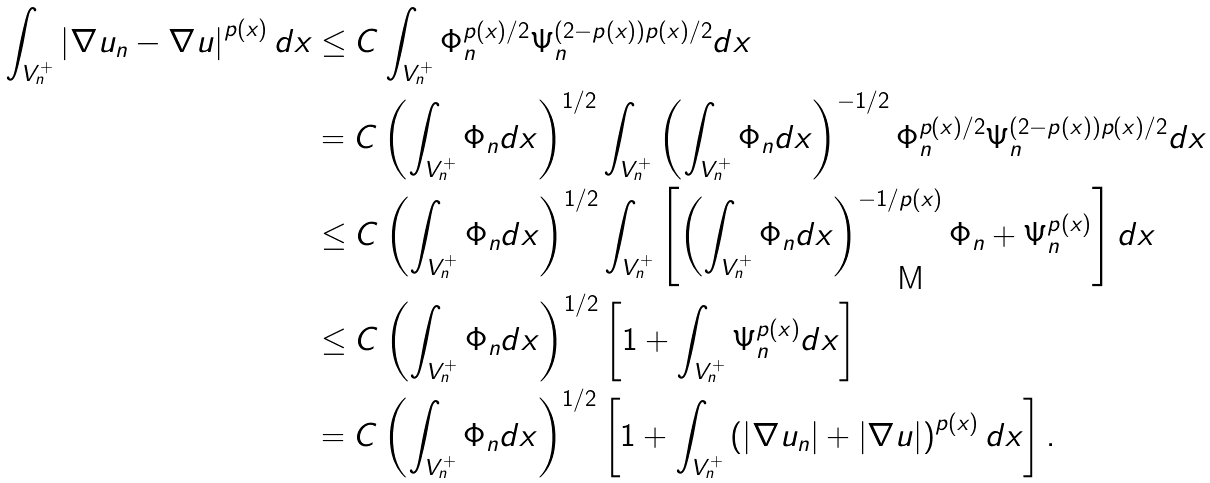<formula> <loc_0><loc_0><loc_500><loc_500>\int _ { V _ { n } ^ { + } } \left | \nabla u _ { n } - \nabla u \right | ^ { p ( x ) } d x & \leq C \int _ { V _ { n } ^ { + } } \Phi _ { n } ^ { p ( x ) / 2 } \Psi _ { n } ^ { ( 2 - p ( x ) ) p ( x ) / 2 } d x \\ & = C \left ( \int _ { V _ { n } ^ { + } } \Phi _ { n } d x \right ) ^ { 1 / 2 } \int _ { V _ { n } ^ { + } } \left ( \int _ { V _ { n } ^ { + } } \Phi _ { n } d x \right ) ^ { - 1 / 2 } \Phi _ { n } ^ { p ( x ) / 2 } \Psi _ { n } ^ { ( 2 - p ( x ) ) p ( x ) / 2 } d x \\ & \leq C \left ( \int _ { V _ { n } ^ { + } } \Phi _ { n } d x \right ) ^ { 1 / 2 } \int _ { V _ { n } ^ { + } } \left [ \left ( \int _ { V _ { n } ^ { + } } \Phi _ { n } d x \right ) ^ { - 1 / p ( x ) } \Phi _ { n } + \Psi _ { n } ^ { p ( x ) } \right ] d x \\ & \leq C \left ( \int _ { V _ { n } ^ { + } } \Phi _ { n } d x \right ) ^ { 1 / 2 } \left [ 1 + \int _ { V _ { n } ^ { + } } \Psi _ { n } ^ { p ( x ) } d x \right ] \\ & = C \left ( \int _ { V _ { n } ^ { + } } \Phi _ { n } d x \right ) ^ { 1 / 2 } \left [ 1 + \int _ { V _ { n } ^ { + } } \left ( \left | \nabla u _ { n } \right | + \left | \nabla u \right | \right ) ^ { p ( x ) } d x \right ] .</formula> 